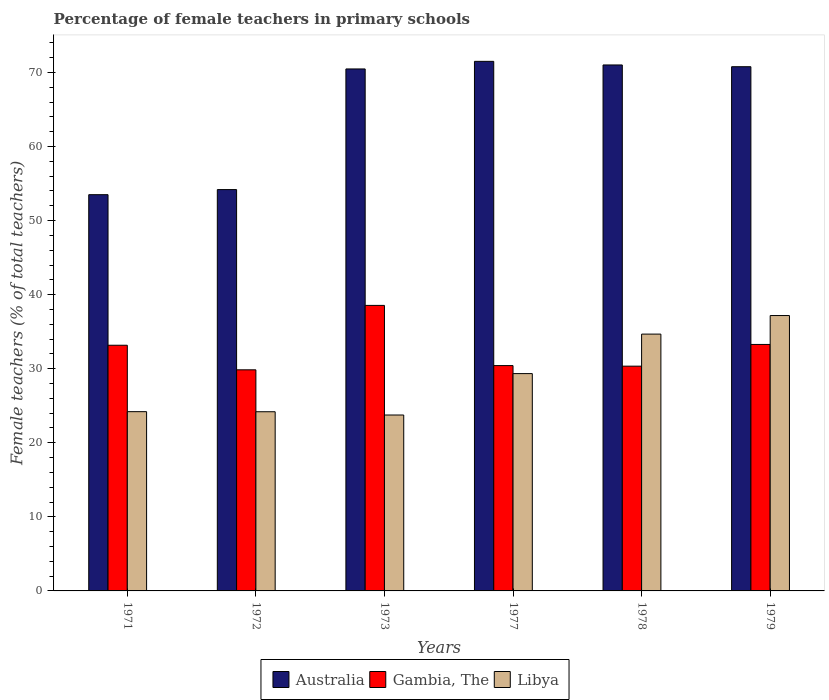How many different coloured bars are there?
Offer a terse response. 3. In how many cases, is the number of bars for a given year not equal to the number of legend labels?
Make the answer very short. 0. What is the percentage of female teachers in Gambia, The in 1972?
Give a very brief answer. 29.85. Across all years, what is the maximum percentage of female teachers in Australia?
Ensure brevity in your answer.  71.5. Across all years, what is the minimum percentage of female teachers in Australia?
Make the answer very short. 53.5. What is the total percentage of female teachers in Libya in the graph?
Your answer should be compact. 173.35. What is the difference between the percentage of female teachers in Australia in 1971 and that in 1979?
Your response must be concise. -17.28. What is the difference between the percentage of female teachers in Australia in 1973 and the percentage of female teachers in Libya in 1978?
Offer a terse response. 35.8. What is the average percentage of female teachers in Libya per year?
Make the answer very short. 28.89. In the year 1972, what is the difference between the percentage of female teachers in Libya and percentage of female teachers in Australia?
Give a very brief answer. -30. In how many years, is the percentage of female teachers in Libya greater than 54 %?
Give a very brief answer. 0. What is the ratio of the percentage of female teachers in Australia in 1977 to that in 1978?
Ensure brevity in your answer.  1.01. What is the difference between the highest and the second highest percentage of female teachers in Gambia, The?
Your answer should be compact. 5.27. What is the difference between the highest and the lowest percentage of female teachers in Australia?
Your answer should be very brief. 18. In how many years, is the percentage of female teachers in Libya greater than the average percentage of female teachers in Libya taken over all years?
Give a very brief answer. 3. Is the sum of the percentage of female teachers in Gambia, The in 1971 and 1972 greater than the maximum percentage of female teachers in Australia across all years?
Provide a short and direct response. No. What does the 1st bar from the left in 1977 represents?
Keep it short and to the point. Australia. What does the 1st bar from the right in 1973 represents?
Your response must be concise. Libya. What is the difference between two consecutive major ticks on the Y-axis?
Keep it short and to the point. 10. Are the values on the major ticks of Y-axis written in scientific E-notation?
Offer a terse response. No. Does the graph contain grids?
Ensure brevity in your answer.  No. How many legend labels are there?
Offer a terse response. 3. How are the legend labels stacked?
Ensure brevity in your answer.  Horizontal. What is the title of the graph?
Keep it short and to the point. Percentage of female teachers in primary schools. What is the label or title of the X-axis?
Ensure brevity in your answer.  Years. What is the label or title of the Y-axis?
Ensure brevity in your answer.  Female teachers (% of total teachers). What is the Female teachers (% of total teachers) of Australia in 1971?
Give a very brief answer. 53.5. What is the Female teachers (% of total teachers) in Gambia, The in 1971?
Your answer should be compact. 33.17. What is the Female teachers (% of total teachers) of Libya in 1971?
Your answer should be very brief. 24.2. What is the Female teachers (% of total teachers) of Australia in 1972?
Your answer should be compact. 54.19. What is the Female teachers (% of total teachers) in Gambia, The in 1972?
Keep it short and to the point. 29.85. What is the Female teachers (% of total teachers) in Libya in 1972?
Your answer should be very brief. 24.19. What is the Female teachers (% of total teachers) in Australia in 1973?
Make the answer very short. 70.48. What is the Female teachers (% of total teachers) of Gambia, The in 1973?
Provide a succinct answer. 38.55. What is the Female teachers (% of total teachers) of Libya in 1973?
Your answer should be compact. 23.75. What is the Female teachers (% of total teachers) in Australia in 1977?
Keep it short and to the point. 71.5. What is the Female teachers (% of total teachers) in Gambia, The in 1977?
Offer a very short reply. 30.43. What is the Female teachers (% of total teachers) in Libya in 1977?
Offer a terse response. 29.34. What is the Female teachers (% of total teachers) in Australia in 1978?
Provide a succinct answer. 71.02. What is the Female teachers (% of total teachers) in Gambia, The in 1978?
Your answer should be very brief. 30.35. What is the Female teachers (% of total teachers) in Libya in 1978?
Make the answer very short. 34.68. What is the Female teachers (% of total teachers) in Australia in 1979?
Make the answer very short. 70.78. What is the Female teachers (% of total teachers) in Gambia, The in 1979?
Provide a short and direct response. 33.28. What is the Female teachers (% of total teachers) of Libya in 1979?
Your answer should be compact. 37.18. Across all years, what is the maximum Female teachers (% of total teachers) of Australia?
Your answer should be compact. 71.5. Across all years, what is the maximum Female teachers (% of total teachers) in Gambia, The?
Make the answer very short. 38.55. Across all years, what is the maximum Female teachers (% of total teachers) of Libya?
Make the answer very short. 37.18. Across all years, what is the minimum Female teachers (% of total teachers) of Australia?
Offer a terse response. 53.5. Across all years, what is the minimum Female teachers (% of total teachers) in Gambia, The?
Offer a very short reply. 29.85. Across all years, what is the minimum Female teachers (% of total teachers) in Libya?
Make the answer very short. 23.75. What is the total Female teachers (% of total teachers) of Australia in the graph?
Offer a very short reply. 391.47. What is the total Female teachers (% of total teachers) in Gambia, The in the graph?
Provide a succinct answer. 195.63. What is the total Female teachers (% of total teachers) of Libya in the graph?
Provide a succinct answer. 173.35. What is the difference between the Female teachers (% of total teachers) of Australia in 1971 and that in 1972?
Offer a terse response. -0.69. What is the difference between the Female teachers (% of total teachers) of Gambia, The in 1971 and that in 1972?
Your answer should be compact. 3.32. What is the difference between the Female teachers (% of total teachers) in Libya in 1971 and that in 1972?
Your answer should be very brief. 0.01. What is the difference between the Female teachers (% of total teachers) of Australia in 1971 and that in 1973?
Make the answer very short. -16.98. What is the difference between the Female teachers (% of total teachers) of Gambia, The in 1971 and that in 1973?
Make the answer very short. -5.38. What is the difference between the Female teachers (% of total teachers) in Libya in 1971 and that in 1973?
Give a very brief answer. 0.45. What is the difference between the Female teachers (% of total teachers) of Australia in 1971 and that in 1977?
Your answer should be very brief. -18. What is the difference between the Female teachers (% of total teachers) of Gambia, The in 1971 and that in 1977?
Provide a succinct answer. 2.75. What is the difference between the Female teachers (% of total teachers) in Libya in 1971 and that in 1977?
Offer a very short reply. -5.14. What is the difference between the Female teachers (% of total teachers) of Australia in 1971 and that in 1978?
Provide a succinct answer. -17.52. What is the difference between the Female teachers (% of total teachers) in Gambia, The in 1971 and that in 1978?
Ensure brevity in your answer.  2.83. What is the difference between the Female teachers (% of total teachers) in Libya in 1971 and that in 1978?
Provide a succinct answer. -10.47. What is the difference between the Female teachers (% of total teachers) of Australia in 1971 and that in 1979?
Offer a terse response. -17.28. What is the difference between the Female teachers (% of total teachers) in Gambia, The in 1971 and that in 1979?
Give a very brief answer. -0.11. What is the difference between the Female teachers (% of total teachers) in Libya in 1971 and that in 1979?
Keep it short and to the point. -12.98. What is the difference between the Female teachers (% of total teachers) in Australia in 1972 and that in 1973?
Your answer should be compact. -16.29. What is the difference between the Female teachers (% of total teachers) in Gambia, The in 1972 and that in 1973?
Offer a terse response. -8.7. What is the difference between the Female teachers (% of total teachers) in Libya in 1972 and that in 1973?
Keep it short and to the point. 0.44. What is the difference between the Female teachers (% of total teachers) of Australia in 1972 and that in 1977?
Ensure brevity in your answer.  -17.31. What is the difference between the Female teachers (% of total teachers) of Gambia, The in 1972 and that in 1977?
Your answer should be compact. -0.57. What is the difference between the Female teachers (% of total teachers) in Libya in 1972 and that in 1977?
Provide a succinct answer. -5.15. What is the difference between the Female teachers (% of total teachers) of Australia in 1972 and that in 1978?
Offer a very short reply. -16.83. What is the difference between the Female teachers (% of total teachers) of Gambia, The in 1972 and that in 1978?
Offer a very short reply. -0.49. What is the difference between the Female teachers (% of total teachers) of Libya in 1972 and that in 1978?
Ensure brevity in your answer.  -10.48. What is the difference between the Female teachers (% of total teachers) of Australia in 1972 and that in 1979?
Offer a terse response. -16.59. What is the difference between the Female teachers (% of total teachers) of Gambia, The in 1972 and that in 1979?
Keep it short and to the point. -3.43. What is the difference between the Female teachers (% of total teachers) of Libya in 1972 and that in 1979?
Your answer should be very brief. -12.99. What is the difference between the Female teachers (% of total teachers) in Australia in 1973 and that in 1977?
Make the answer very short. -1.03. What is the difference between the Female teachers (% of total teachers) in Gambia, The in 1973 and that in 1977?
Give a very brief answer. 8.13. What is the difference between the Female teachers (% of total teachers) in Libya in 1973 and that in 1977?
Your response must be concise. -5.59. What is the difference between the Female teachers (% of total teachers) in Australia in 1973 and that in 1978?
Give a very brief answer. -0.54. What is the difference between the Female teachers (% of total teachers) of Gambia, The in 1973 and that in 1978?
Provide a succinct answer. 8.21. What is the difference between the Female teachers (% of total teachers) of Libya in 1973 and that in 1978?
Keep it short and to the point. -10.92. What is the difference between the Female teachers (% of total teachers) of Australia in 1973 and that in 1979?
Your answer should be compact. -0.3. What is the difference between the Female teachers (% of total teachers) in Gambia, The in 1973 and that in 1979?
Provide a succinct answer. 5.27. What is the difference between the Female teachers (% of total teachers) in Libya in 1973 and that in 1979?
Provide a succinct answer. -13.43. What is the difference between the Female teachers (% of total teachers) of Australia in 1977 and that in 1978?
Your answer should be compact. 0.49. What is the difference between the Female teachers (% of total teachers) in Gambia, The in 1977 and that in 1978?
Your answer should be very brief. 0.08. What is the difference between the Female teachers (% of total teachers) of Libya in 1977 and that in 1978?
Your answer should be compact. -5.33. What is the difference between the Female teachers (% of total teachers) in Australia in 1977 and that in 1979?
Offer a very short reply. 0.72. What is the difference between the Female teachers (% of total teachers) in Gambia, The in 1977 and that in 1979?
Your response must be concise. -2.85. What is the difference between the Female teachers (% of total teachers) of Libya in 1977 and that in 1979?
Offer a very short reply. -7.84. What is the difference between the Female teachers (% of total teachers) of Australia in 1978 and that in 1979?
Give a very brief answer. 0.24. What is the difference between the Female teachers (% of total teachers) in Gambia, The in 1978 and that in 1979?
Make the answer very short. -2.93. What is the difference between the Female teachers (% of total teachers) in Libya in 1978 and that in 1979?
Provide a short and direct response. -2.51. What is the difference between the Female teachers (% of total teachers) in Australia in 1971 and the Female teachers (% of total teachers) in Gambia, The in 1972?
Give a very brief answer. 23.65. What is the difference between the Female teachers (% of total teachers) of Australia in 1971 and the Female teachers (% of total teachers) of Libya in 1972?
Your response must be concise. 29.31. What is the difference between the Female teachers (% of total teachers) of Gambia, The in 1971 and the Female teachers (% of total teachers) of Libya in 1972?
Offer a very short reply. 8.98. What is the difference between the Female teachers (% of total teachers) of Australia in 1971 and the Female teachers (% of total teachers) of Gambia, The in 1973?
Provide a succinct answer. 14.95. What is the difference between the Female teachers (% of total teachers) in Australia in 1971 and the Female teachers (% of total teachers) in Libya in 1973?
Offer a terse response. 29.75. What is the difference between the Female teachers (% of total teachers) of Gambia, The in 1971 and the Female teachers (% of total teachers) of Libya in 1973?
Keep it short and to the point. 9.42. What is the difference between the Female teachers (% of total teachers) of Australia in 1971 and the Female teachers (% of total teachers) of Gambia, The in 1977?
Ensure brevity in your answer.  23.08. What is the difference between the Female teachers (% of total teachers) in Australia in 1971 and the Female teachers (% of total teachers) in Libya in 1977?
Make the answer very short. 24.16. What is the difference between the Female teachers (% of total teachers) in Gambia, The in 1971 and the Female teachers (% of total teachers) in Libya in 1977?
Provide a succinct answer. 3.83. What is the difference between the Female teachers (% of total teachers) in Australia in 1971 and the Female teachers (% of total teachers) in Gambia, The in 1978?
Ensure brevity in your answer.  23.15. What is the difference between the Female teachers (% of total teachers) in Australia in 1971 and the Female teachers (% of total teachers) in Libya in 1978?
Make the answer very short. 18.82. What is the difference between the Female teachers (% of total teachers) in Gambia, The in 1971 and the Female teachers (% of total teachers) in Libya in 1978?
Offer a very short reply. -1.5. What is the difference between the Female teachers (% of total teachers) in Australia in 1971 and the Female teachers (% of total teachers) in Gambia, The in 1979?
Offer a very short reply. 20.22. What is the difference between the Female teachers (% of total teachers) in Australia in 1971 and the Female teachers (% of total teachers) in Libya in 1979?
Ensure brevity in your answer.  16.32. What is the difference between the Female teachers (% of total teachers) in Gambia, The in 1971 and the Female teachers (% of total teachers) in Libya in 1979?
Your answer should be compact. -4.01. What is the difference between the Female teachers (% of total teachers) in Australia in 1972 and the Female teachers (% of total teachers) in Gambia, The in 1973?
Offer a terse response. 15.64. What is the difference between the Female teachers (% of total teachers) in Australia in 1972 and the Female teachers (% of total teachers) in Libya in 1973?
Make the answer very short. 30.44. What is the difference between the Female teachers (% of total teachers) of Gambia, The in 1972 and the Female teachers (% of total teachers) of Libya in 1973?
Give a very brief answer. 6.1. What is the difference between the Female teachers (% of total teachers) of Australia in 1972 and the Female teachers (% of total teachers) of Gambia, The in 1977?
Offer a terse response. 23.76. What is the difference between the Female teachers (% of total teachers) in Australia in 1972 and the Female teachers (% of total teachers) in Libya in 1977?
Offer a terse response. 24.85. What is the difference between the Female teachers (% of total teachers) in Gambia, The in 1972 and the Female teachers (% of total teachers) in Libya in 1977?
Your answer should be very brief. 0.51. What is the difference between the Female teachers (% of total teachers) of Australia in 1972 and the Female teachers (% of total teachers) of Gambia, The in 1978?
Offer a terse response. 23.84. What is the difference between the Female teachers (% of total teachers) of Australia in 1972 and the Female teachers (% of total teachers) of Libya in 1978?
Your answer should be compact. 19.51. What is the difference between the Female teachers (% of total teachers) of Gambia, The in 1972 and the Female teachers (% of total teachers) of Libya in 1978?
Provide a succinct answer. -4.82. What is the difference between the Female teachers (% of total teachers) of Australia in 1972 and the Female teachers (% of total teachers) of Gambia, The in 1979?
Your answer should be compact. 20.91. What is the difference between the Female teachers (% of total teachers) in Australia in 1972 and the Female teachers (% of total teachers) in Libya in 1979?
Provide a succinct answer. 17.01. What is the difference between the Female teachers (% of total teachers) of Gambia, The in 1972 and the Female teachers (% of total teachers) of Libya in 1979?
Offer a terse response. -7.33. What is the difference between the Female teachers (% of total teachers) of Australia in 1973 and the Female teachers (% of total teachers) of Gambia, The in 1977?
Give a very brief answer. 40.05. What is the difference between the Female teachers (% of total teachers) of Australia in 1973 and the Female teachers (% of total teachers) of Libya in 1977?
Make the answer very short. 41.14. What is the difference between the Female teachers (% of total teachers) of Gambia, The in 1973 and the Female teachers (% of total teachers) of Libya in 1977?
Make the answer very short. 9.21. What is the difference between the Female teachers (% of total teachers) in Australia in 1973 and the Female teachers (% of total teachers) in Gambia, The in 1978?
Give a very brief answer. 40.13. What is the difference between the Female teachers (% of total teachers) in Australia in 1973 and the Female teachers (% of total teachers) in Libya in 1978?
Give a very brief answer. 35.8. What is the difference between the Female teachers (% of total teachers) of Gambia, The in 1973 and the Female teachers (% of total teachers) of Libya in 1978?
Provide a succinct answer. 3.88. What is the difference between the Female teachers (% of total teachers) of Australia in 1973 and the Female teachers (% of total teachers) of Gambia, The in 1979?
Provide a succinct answer. 37.2. What is the difference between the Female teachers (% of total teachers) of Australia in 1973 and the Female teachers (% of total teachers) of Libya in 1979?
Your answer should be compact. 33.29. What is the difference between the Female teachers (% of total teachers) of Gambia, The in 1973 and the Female teachers (% of total teachers) of Libya in 1979?
Offer a terse response. 1.37. What is the difference between the Female teachers (% of total teachers) of Australia in 1977 and the Female teachers (% of total teachers) of Gambia, The in 1978?
Make the answer very short. 41.16. What is the difference between the Female teachers (% of total teachers) in Australia in 1977 and the Female teachers (% of total teachers) in Libya in 1978?
Give a very brief answer. 36.83. What is the difference between the Female teachers (% of total teachers) of Gambia, The in 1977 and the Female teachers (% of total teachers) of Libya in 1978?
Your answer should be compact. -4.25. What is the difference between the Female teachers (% of total teachers) in Australia in 1977 and the Female teachers (% of total teachers) in Gambia, The in 1979?
Ensure brevity in your answer.  38.22. What is the difference between the Female teachers (% of total teachers) of Australia in 1977 and the Female teachers (% of total teachers) of Libya in 1979?
Ensure brevity in your answer.  34.32. What is the difference between the Female teachers (% of total teachers) in Gambia, The in 1977 and the Female teachers (% of total teachers) in Libya in 1979?
Offer a terse response. -6.76. What is the difference between the Female teachers (% of total teachers) of Australia in 1978 and the Female teachers (% of total teachers) of Gambia, The in 1979?
Your response must be concise. 37.74. What is the difference between the Female teachers (% of total teachers) of Australia in 1978 and the Female teachers (% of total teachers) of Libya in 1979?
Your answer should be compact. 33.83. What is the difference between the Female teachers (% of total teachers) in Gambia, The in 1978 and the Female teachers (% of total teachers) in Libya in 1979?
Your answer should be very brief. -6.84. What is the average Female teachers (% of total teachers) of Australia per year?
Offer a terse response. 65.25. What is the average Female teachers (% of total teachers) in Gambia, The per year?
Give a very brief answer. 32.61. What is the average Female teachers (% of total teachers) in Libya per year?
Your answer should be very brief. 28.89. In the year 1971, what is the difference between the Female teachers (% of total teachers) of Australia and Female teachers (% of total teachers) of Gambia, The?
Make the answer very short. 20.33. In the year 1971, what is the difference between the Female teachers (% of total teachers) of Australia and Female teachers (% of total teachers) of Libya?
Your answer should be compact. 29.3. In the year 1971, what is the difference between the Female teachers (% of total teachers) of Gambia, The and Female teachers (% of total teachers) of Libya?
Keep it short and to the point. 8.97. In the year 1972, what is the difference between the Female teachers (% of total teachers) of Australia and Female teachers (% of total teachers) of Gambia, The?
Ensure brevity in your answer.  24.34. In the year 1972, what is the difference between the Female teachers (% of total teachers) of Australia and Female teachers (% of total teachers) of Libya?
Your answer should be very brief. 30. In the year 1972, what is the difference between the Female teachers (% of total teachers) in Gambia, The and Female teachers (% of total teachers) in Libya?
Offer a terse response. 5.66. In the year 1973, what is the difference between the Female teachers (% of total teachers) in Australia and Female teachers (% of total teachers) in Gambia, The?
Your answer should be very brief. 31.93. In the year 1973, what is the difference between the Female teachers (% of total teachers) of Australia and Female teachers (% of total teachers) of Libya?
Your response must be concise. 46.73. In the year 1973, what is the difference between the Female teachers (% of total teachers) of Gambia, The and Female teachers (% of total teachers) of Libya?
Make the answer very short. 14.8. In the year 1977, what is the difference between the Female teachers (% of total teachers) in Australia and Female teachers (% of total teachers) in Gambia, The?
Your answer should be very brief. 41.08. In the year 1977, what is the difference between the Female teachers (% of total teachers) of Australia and Female teachers (% of total teachers) of Libya?
Your answer should be compact. 42.16. In the year 1977, what is the difference between the Female teachers (% of total teachers) in Gambia, The and Female teachers (% of total teachers) in Libya?
Keep it short and to the point. 1.08. In the year 1978, what is the difference between the Female teachers (% of total teachers) of Australia and Female teachers (% of total teachers) of Gambia, The?
Your answer should be compact. 40.67. In the year 1978, what is the difference between the Female teachers (% of total teachers) in Australia and Female teachers (% of total teachers) in Libya?
Your response must be concise. 36.34. In the year 1978, what is the difference between the Female teachers (% of total teachers) in Gambia, The and Female teachers (% of total teachers) in Libya?
Offer a terse response. -4.33. In the year 1979, what is the difference between the Female teachers (% of total teachers) in Australia and Female teachers (% of total teachers) in Gambia, The?
Make the answer very short. 37.5. In the year 1979, what is the difference between the Female teachers (% of total teachers) of Australia and Female teachers (% of total teachers) of Libya?
Offer a very short reply. 33.6. In the year 1979, what is the difference between the Female teachers (% of total teachers) of Gambia, The and Female teachers (% of total teachers) of Libya?
Keep it short and to the point. -3.9. What is the ratio of the Female teachers (% of total teachers) in Australia in 1971 to that in 1972?
Offer a very short reply. 0.99. What is the ratio of the Female teachers (% of total teachers) in Gambia, The in 1971 to that in 1972?
Provide a short and direct response. 1.11. What is the ratio of the Female teachers (% of total teachers) in Libya in 1971 to that in 1972?
Your answer should be compact. 1. What is the ratio of the Female teachers (% of total teachers) in Australia in 1971 to that in 1973?
Keep it short and to the point. 0.76. What is the ratio of the Female teachers (% of total teachers) of Gambia, The in 1971 to that in 1973?
Keep it short and to the point. 0.86. What is the ratio of the Female teachers (% of total teachers) of Australia in 1971 to that in 1977?
Offer a terse response. 0.75. What is the ratio of the Female teachers (% of total teachers) of Gambia, The in 1971 to that in 1977?
Give a very brief answer. 1.09. What is the ratio of the Female teachers (% of total teachers) in Libya in 1971 to that in 1977?
Ensure brevity in your answer.  0.82. What is the ratio of the Female teachers (% of total teachers) in Australia in 1971 to that in 1978?
Ensure brevity in your answer.  0.75. What is the ratio of the Female teachers (% of total teachers) in Gambia, The in 1971 to that in 1978?
Provide a succinct answer. 1.09. What is the ratio of the Female teachers (% of total teachers) in Libya in 1971 to that in 1978?
Your answer should be compact. 0.7. What is the ratio of the Female teachers (% of total teachers) of Australia in 1971 to that in 1979?
Your response must be concise. 0.76. What is the ratio of the Female teachers (% of total teachers) of Gambia, The in 1971 to that in 1979?
Offer a terse response. 1. What is the ratio of the Female teachers (% of total teachers) in Libya in 1971 to that in 1979?
Your answer should be very brief. 0.65. What is the ratio of the Female teachers (% of total teachers) of Australia in 1972 to that in 1973?
Your response must be concise. 0.77. What is the ratio of the Female teachers (% of total teachers) in Gambia, The in 1972 to that in 1973?
Give a very brief answer. 0.77. What is the ratio of the Female teachers (% of total teachers) of Libya in 1972 to that in 1973?
Provide a short and direct response. 1.02. What is the ratio of the Female teachers (% of total teachers) in Australia in 1972 to that in 1977?
Ensure brevity in your answer.  0.76. What is the ratio of the Female teachers (% of total teachers) in Gambia, The in 1972 to that in 1977?
Make the answer very short. 0.98. What is the ratio of the Female teachers (% of total teachers) of Libya in 1972 to that in 1977?
Your answer should be compact. 0.82. What is the ratio of the Female teachers (% of total teachers) in Australia in 1972 to that in 1978?
Your answer should be compact. 0.76. What is the ratio of the Female teachers (% of total teachers) of Gambia, The in 1972 to that in 1978?
Give a very brief answer. 0.98. What is the ratio of the Female teachers (% of total teachers) in Libya in 1972 to that in 1978?
Make the answer very short. 0.7. What is the ratio of the Female teachers (% of total teachers) in Australia in 1972 to that in 1979?
Give a very brief answer. 0.77. What is the ratio of the Female teachers (% of total teachers) of Gambia, The in 1972 to that in 1979?
Give a very brief answer. 0.9. What is the ratio of the Female teachers (% of total teachers) in Libya in 1972 to that in 1979?
Offer a very short reply. 0.65. What is the ratio of the Female teachers (% of total teachers) of Australia in 1973 to that in 1977?
Give a very brief answer. 0.99. What is the ratio of the Female teachers (% of total teachers) of Gambia, The in 1973 to that in 1977?
Your answer should be compact. 1.27. What is the ratio of the Female teachers (% of total teachers) of Libya in 1973 to that in 1977?
Ensure brevity in your answer.  0.81. What is the ratio of the Female teachers (% of total teachers) of Australia in 1973 to that in 1978?
Offer a very short reply. 0.99. What is the ratio of the Female teachers (% of total teachers) in Gambia, The in 1973 to that in 1978?
Make the answer very short. 1.27. What is the ratio of the Female teachers (% of total teachers) of Libya in 1973 to that in 1978?
Provide a short and direct response. 0.69. What is the ratio of the Female teachers (% of total teachers) in Australia in 1973 to that in 1979?
Offer a terse response. 1. What is the ratio of the Female teachers (% of total teachers) in Gambia, The in 1973 to that in 1979?
Your response must be concise. 1.16. What is the ratio of the Female teachers (% of total teachers) of Libya in 1973 to that in 1979?
Keep it short and to the point. 0.64. What is the ratio of the Female teachers (% of total teachers) of Libya in 1977 to that in 1978?
Provide a short and direct response. 0.85. What is the ratio of the Female teachers (% of total teachers) in Australia in 1977 to that in 1979?
Make the answer very short. 1.01. What is the ratio of the Female teachers (% of total teachers) of Gambia, The in 1977 to that in 1979?
Your answer should be very brief. 0.91. What is the ratio of the Female teachers (% of total teachers) of Libya in 1977 to that in 1979?
Provide a succinct answer. 0.79. What is the ratio of the Female teachers (% of total teachers) in Gambia, The in 1978 to that in 1979?
Make the answer very short. 0.91. What is the ratio of the Female teachers (% of total teachers) in Libya in 1978 to that in 1979?
Your response must be concise. 0.93. What is the difference between the highest and the second highest Female teachers (% of total teachers) of Australia?
Provide a succinct answer. 0.49. What is the difference between the highest and the second highest Female teachers (% of total teachers) in Gambia, The?
Provide a short and direct response. 5.27. What is the difference between the highest and the second highest Female teachers (% of total teachers) of Libya?
Offer a very short reply. 2.51. What is the difference between the highest and the lowest Female teachers (% of total teachers) of Australia?
Provide a short and direct response. 18. What is the difference between the highest and the lowest Female teachers (% of total teachers) in Gambia, The?
Provide a succinct answer. 8.7. What is the difference between the highest and the lowest Female teachers (% of total teachers) in Libya?
Your response must be concise. 13.43. 